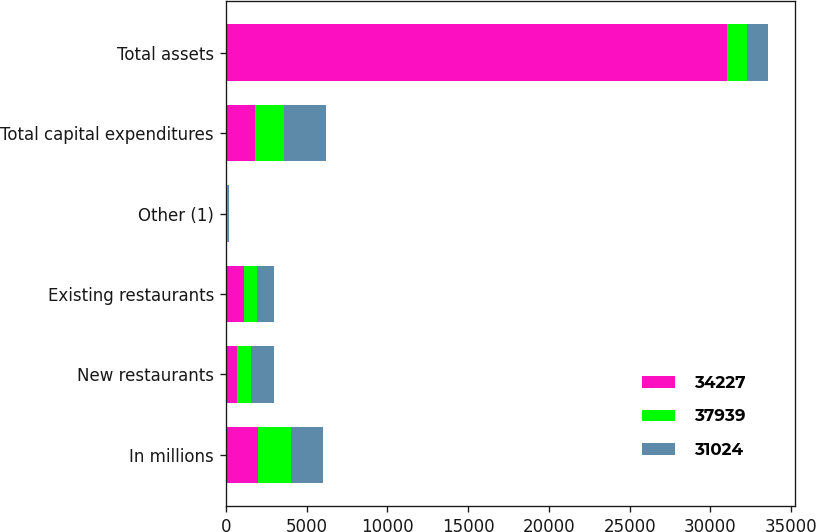Convert chart to OTSL. <chart><loc_0><loc_0><loc_500><loc_500><stacked_bar_chart><ecel><fcel>In millions<fcel>New restaurants<fcel>Existing restaurants<fcel>Other (1)<fcel>Total capital expenditures<fcel>Total assets<nl><fcel>34227<fcel>2016<fcel>674<fcel>1108<fcel>39<fcel>1821<fcel>31024<nl><fcel>37939<fcel>2015<fcel>892<fcel>842<fcel>80<fcel>1814<fcel>1271.5<nl><fcel>31024<fcel>2014<fcel>1435<fcel>1044<fcel>104<fcel>2583<fcel>1271.5<nl></chart> 